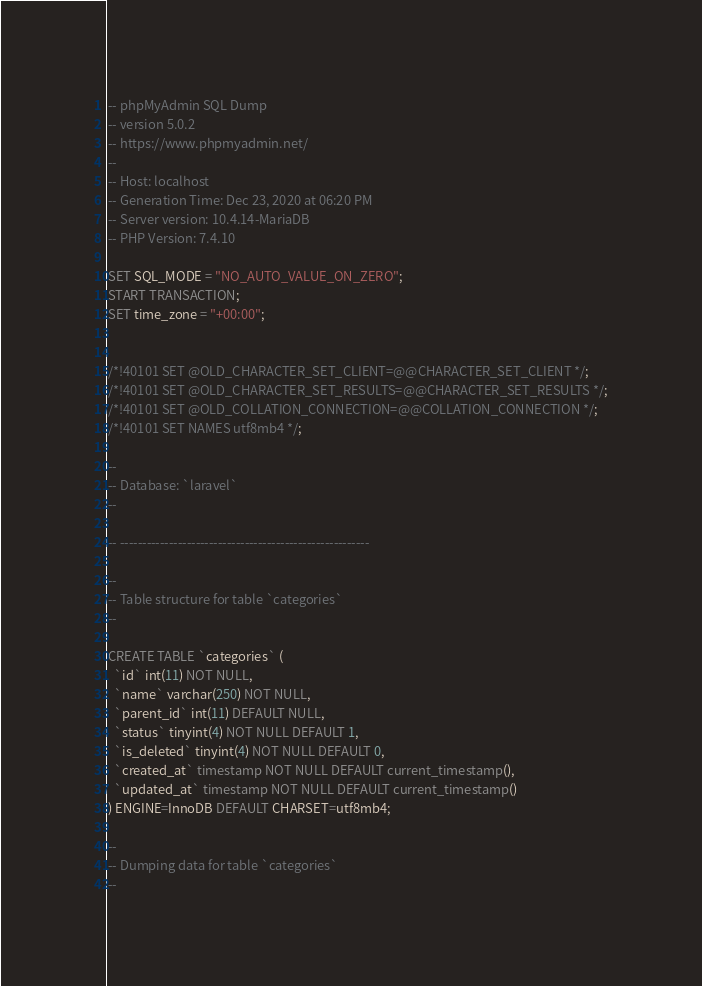Convert code to text. <code><loc_0><loc_0><loc_500><loc_500><_SQL_>-- phpMyAdmin SQL Dump
-- version 5.0.2
-- https://www.phpmyadmin.net/
--
-- Host: localhost
-- Generation Time: Dec 23, 2020 at 06:20 PM
-- Server version: 10.4.14-MariaDB
-- PHP Version: 7.4.10

SET SQL_MODE = "NO_AUTO_VALUE_ON_ZERO";
START TRANSACTION;
SET time_zone = "+00:00";


/*!40101 SET @OLD_CHARACTER_SET_CLIENT=@@CHARACTER_SET_CLIENT */;
/*!40101 SET @OLD_CHARACTER_SET_RESULTS=@@CHARACTER_SET_RESULTS */;
/*!40101 SET @OLD_COLLATION_CONNECTION=@@COLLATION_CONNECTION */;
/*!40101 SET NAMES utf8mb4 */;

--
-- Database: `laravel`
--

-- --------------------------------------------------------

--
-- Table structure for table `categories`
--

CREATE TABLE `categories` (
  `id` int(11) NOT NULL,
  `name` varchar(250) NOT NULL,
  `parent_id` int(11) DEFAULT NULL,
  `status` tinyint(4) NOT NULL DEFAULT 1,
  `is_deleted` tinyint(4) NOT NULL DEFAULT 0,
  `created_at` timestamp NOT NULL DEFAULT current_timestamp(),
  `updated_at` timestamp NOT NULL DEFAULT current_timestamp()
) ENGINE=InnoDB DEFAULT CHARSET=utf8mb4;

--
-- Dumping data for table `categories`
--
</code> 